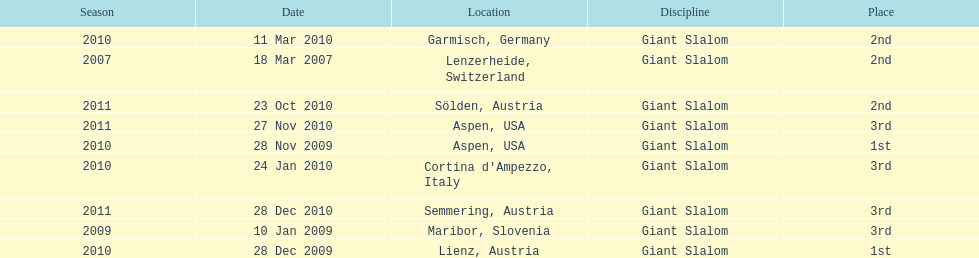Could you help me parse every detail presented in this table? {'header': ['Season', 'Date', 'Location', 'Discipline', 'Place'], 'rows': [['2010', '11 Mar 2010', 'Garmisch, Germany', 'Giant Slalom', '2nd'], ['2007', '18 Mar 2007', 'Lenzerheide, Switzerland', 'Giant Slalom', '2nd'], ['2011', '23 Oct 2010', 'Sölden, Austria', 'Giant Slalom', '2nd'], ['2011', '27 Nov 2010', 'Aspen, USA', 'Giant Slalom', '3rd'], ['2010', '28 Nov 2009', 'Aspen, USA', 'Giant Slalom', '1st'], ['2010', '24 Jan 2010', "Cortina d'Ampezzo, Italy", 'Giant Slalom', '3rd'], ['2011', '28 Dec 2010', 'Semmering, Austria', 'Giant Slalom', '3rd'], ['2009', '10 Jan 2009', 'Maribor, Slovenia', 'Giant Slalom', '3rd'], ['2010', '28 Dec 2009', 'Lienz, Austria', 'Giant Slalom', '1st']]} Aspen and lienz in 2009 are the only races where this racer got what position? 1st. 